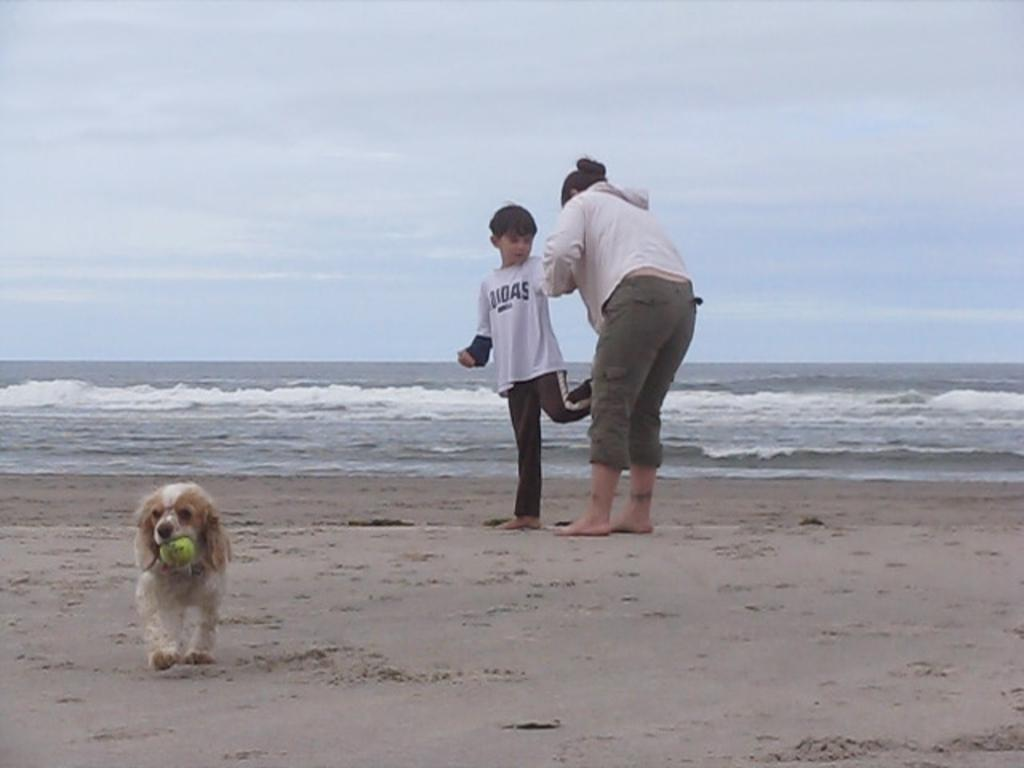What is the main setting of the image? There is a sea in the image. Can you describe the people near the sea shore? There are two people near the sea shore. What animal is present in the image? There is a dog in the image. What is the dog doing in the image? The dog is holding a ball in its mouth. What type of shoes are the people wearing near the sea shore? There is no information about shoes in the image, as the focus is on the sea, people, and dog. 